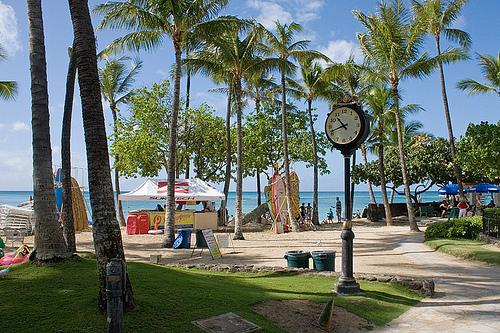These people are most likely on what type of event?

Choices:
A) vacation
B) demolition
C) mob hit
D) diplomatic meeting vacation 